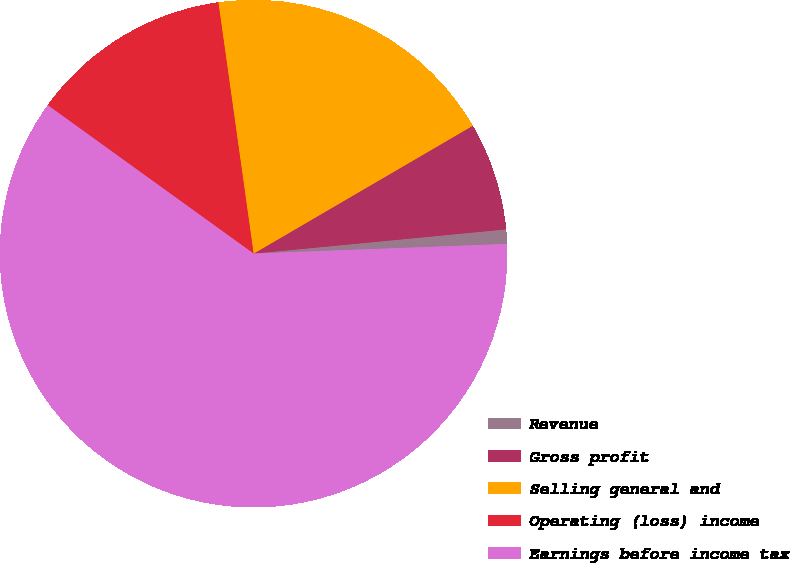Convert chart to OTSL. <chart><loc_0><loc_0><loc_500><loc_500><pie_chart><fcel>Revenue<fcel>Gross profit<fcel>Selling general and<fcel>Operating (loss) income<fcel>Earnings before income tax<nl><fcel>0.92%<fcel>6.88%<fcel>18.81%<fcel>12.84%<fcel>60.55%<nl></chart> 